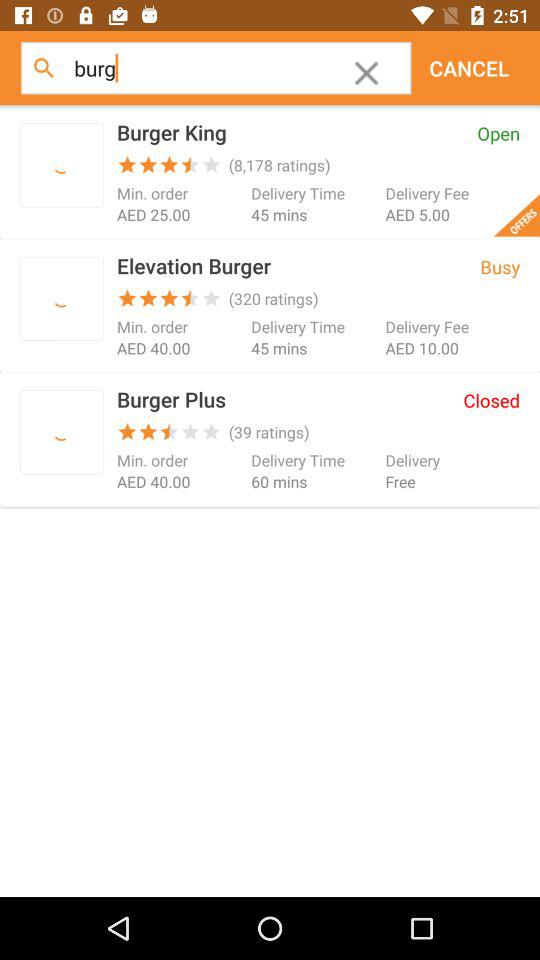What is the delivery time taken by "Burger Plus"? The delivery time taken by "Burger Plus" is 60 minutes. 